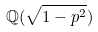Convert formula to latex. <formula><loc_0><loc_0><loc_500><loc_500>\mathbb { Q } ( \sqrt { 1 - p ^ { 2 } } )</formula> 